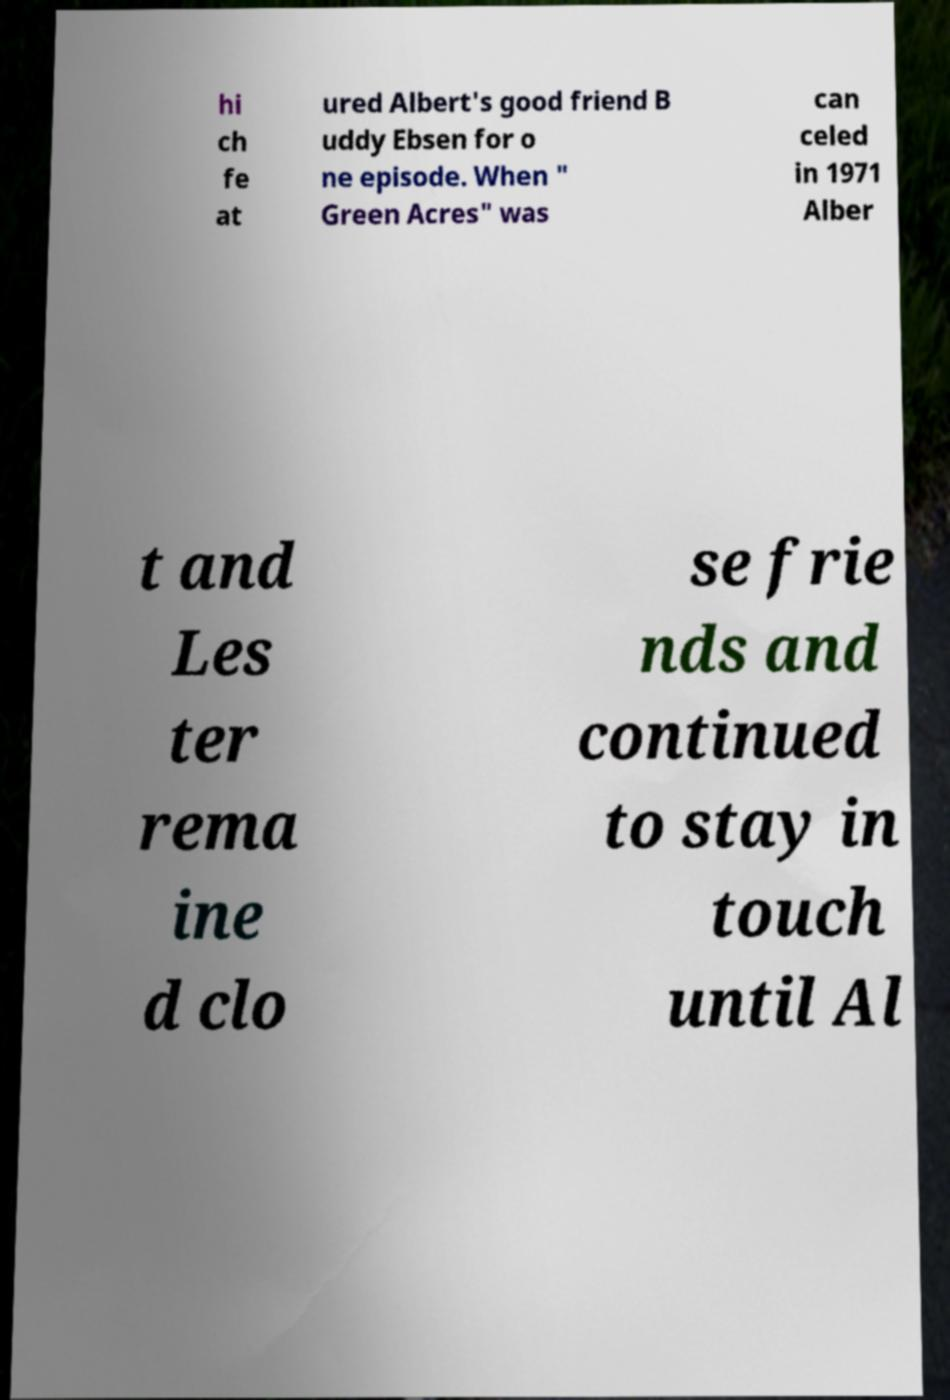Please identify and transcribe the text found in this image. hi ch fe at ured Albert's good friend B uddy Ebsen for o ne episode. When " Green Acres" was can celed in 1971 Alber t and Les ter rema ine d clo se frie nds and continued to stay in touch until Al 